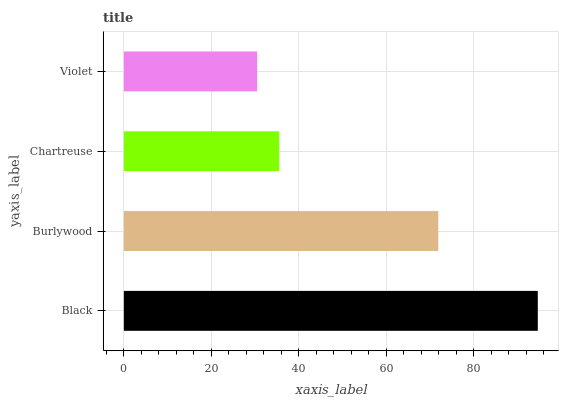Is Violet the minimum?
Answer yes or no. Yes. Is Black the maximum?
Answer yes or no. Yes. Is Burlywood the minimum?
Answer yes or no. No. Is Burlywood the maximum?
Answer yes or no. No. Is Black greater than Burlywood?
Answer yes or no. Yes. Is Burlywood less than Black?
Answer yes or no. Yes. Is Burlywood greater than Black?
Answer yes or no. No. Is Black less than Burlywood?
Answer yes or no. No. Is Burlywood the high median?
Answer yes or no. Yes. Is Chartreuse the low median?
Answer yes or no. Yes. Is Violet the high median?
Answer yes or no. No. Is Violet the low median?
Answer yes or no. No. 